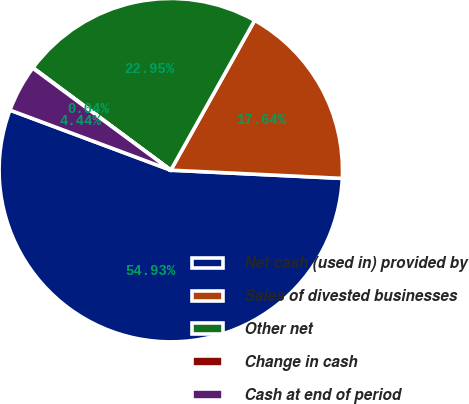Convert chart. <chart><loc_0><loc_0><loc_500><loc_500><pie_chart><fcel>Net cash (used in) provided by<fcel>Sales of divested businesses<fcel>Other net<fcel>Change in cash<fcel>Cash at end of period<nl><fcel>54.92%<fcel>17.64%<fcel>22.95%<fcel>0.04%<fcel>4.44%<nl></chart> 